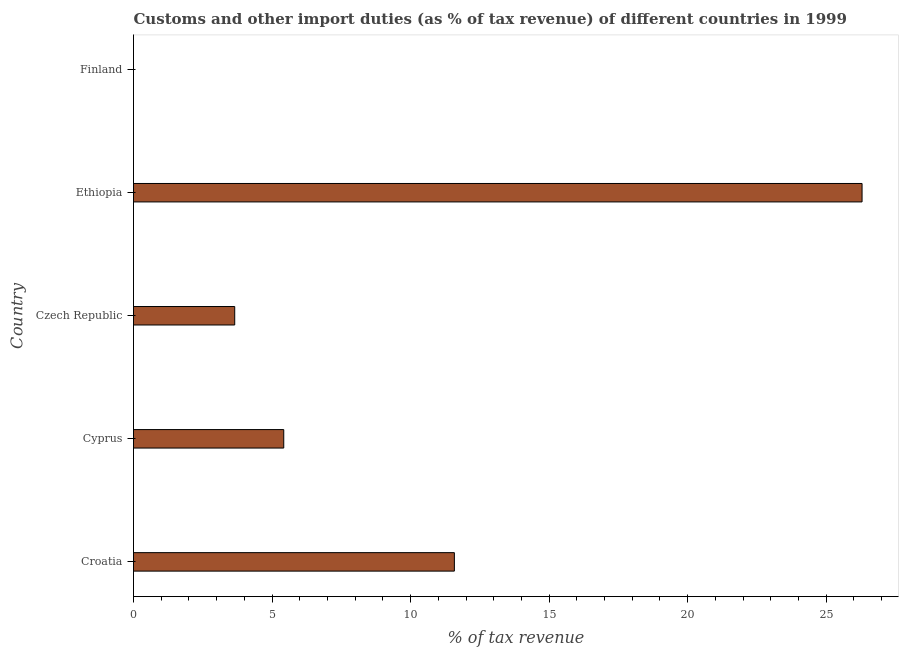What is the title of the graph?
Keep it short and to the point. Customs and other import duties (as % of tax revenue) of different countries in 1999. What is the label or title of the X-axis?
Your response must be concise. % of tax revenue. What is the label or title of the Y-axis?
Your response must be concise. Country. Across all countries, what is the maximum customs and other import duties?
Give a very brief answer. 26.29. In which country was the customs and other import duties maximum?
Offer a very short reply. Ethiopia. What is the sum of the customs and other import duties?
Keep it short and to the point. 46.95. What is the difference between the customs and other import duties in Croatia and Cyprus?
Provide a short and direct response. 6.16. What is the average customs and other import duties per country?
Provide a succinct answer. 9.39. What is the median customs and other import duties?
Offer a very short reply. 5.42. What is the ratio of the customs and other import duties in Cyprus to that in Ethiopia?
Give a very brief answer. 0.21. Is the customs and other import duties in Croatia less than that in Cyprus?
Provide a short and direct response. No. What is the difference between the highest and the second highest customs and other import duties?
Offer a terse response. 14.71. Is the sum of the customs and other import duties in Croatia and Czech Republic greater than the maximum customs and other import duties across all countries?
Your response must be concise. No. What is the difference between the highest and the lowest customs and other import duties?
Provide a succinct answer. 26.29. In how many countries, is the customs and other import duties greater than the average customs and other import duties taken over all countries?
Keep it short and to the point. 2. What is the % of tax revenue of Croatia?
Offer a very short reply. 11.58. What is the % of tax revenue in Cyprus?
Your answer should be compact. 5.42. What is the % of tax revenue in Czech Republic?
Your answer should be very brief. 3.65. What is the % of tax revenue in Ethiopia?
Provide a succinct answer. 26.29. What is the % of tax revenue in Finland?
Your response must be concise. 0. What is the difference between the % of tax revenue in Croatia and Cyprus?
Provide a succinct answer. 6.16. What is the difference between the % of tax revenue in Croatia and Czech Republic?
Give a very brief answer. 7.93. What is the difference between the % of tax revenue in Croatia and Ethiopia?
Your response must be concise. -14.71. What is the difference between the % of tax revenue in Cyprus and Czech Republic?
Ensure brevity in your answer.  1.77. What is the difference between the % of tax revenue in Cyprus and Ethiopia?
Offer a very short reply. -20.87. What is the difference between the % of tax revenue in Czech Republic and Ethiopia?
Give a very brief answer. -22.64. What is the ratio of the % of tax revenue in Croatia to that in Cyprus?
Make the answer very short. 2.14. What is the ratio of the % of tax revenue in Croatia to that in Czech Republic?
Offer a very short reply. 3.17. What is the ratio of the % of tax revenue in Croatia to that in Ethiopia?
Provide a succinct answer. 0.44. What is the ratio of the % of tax revenue in Cyprus to that in Czech Republic?
Ensure brevity in your answer.  1.49. What is the ratio of the % of tax revenue in Cyprus to that in Ethiopia?
Provide a succinct answer. 0.21. What is the ratio of the % of tax revenue in Czech Republic to that in Ethiopia?
Make the answer very short. 0.14. 